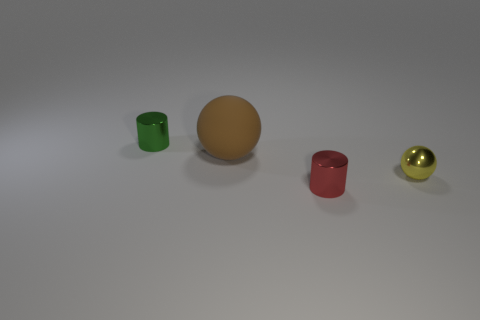Add 3 green shiny objects. How many objects exist? 7 Add 3 shiny balls. How many shiny balls exist? 4 Subtract 0 green cubes. How many objects are left? 4 Subtract all tiny blue cylinders. Subtract all shiny objects. How many objects are left? 1 Add 1 tiny yellow metallic objects. How many tiny yellow metallic objects are left? 2 